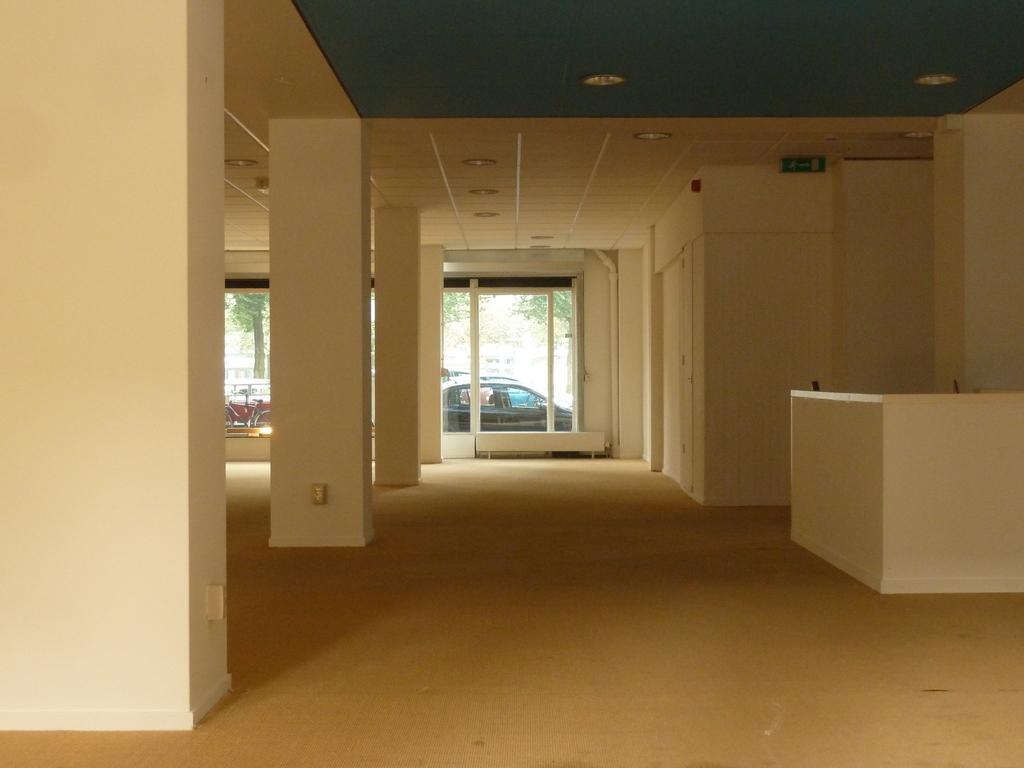Can you describe this image briefly? This is the inside view of a building. Here we can see pillars, glass, board, and ceiling. There are lights and this is floor. From the glass we can see a car, bicycle, and trees. 